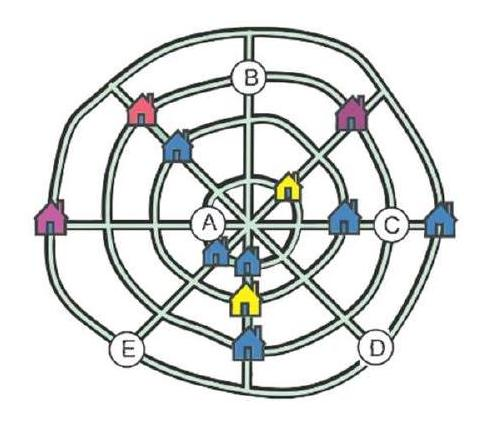A village of 12 houses has four straight streets and four circular streets. The map shows 11 houses. In each straight street there are three houses and in each circular street there are also three houses. Where should the 12th house be placed on this map?
<image1> Choices: ['On A', 'On B', 'On C', 'On D', 'On E'] Answer is D. 